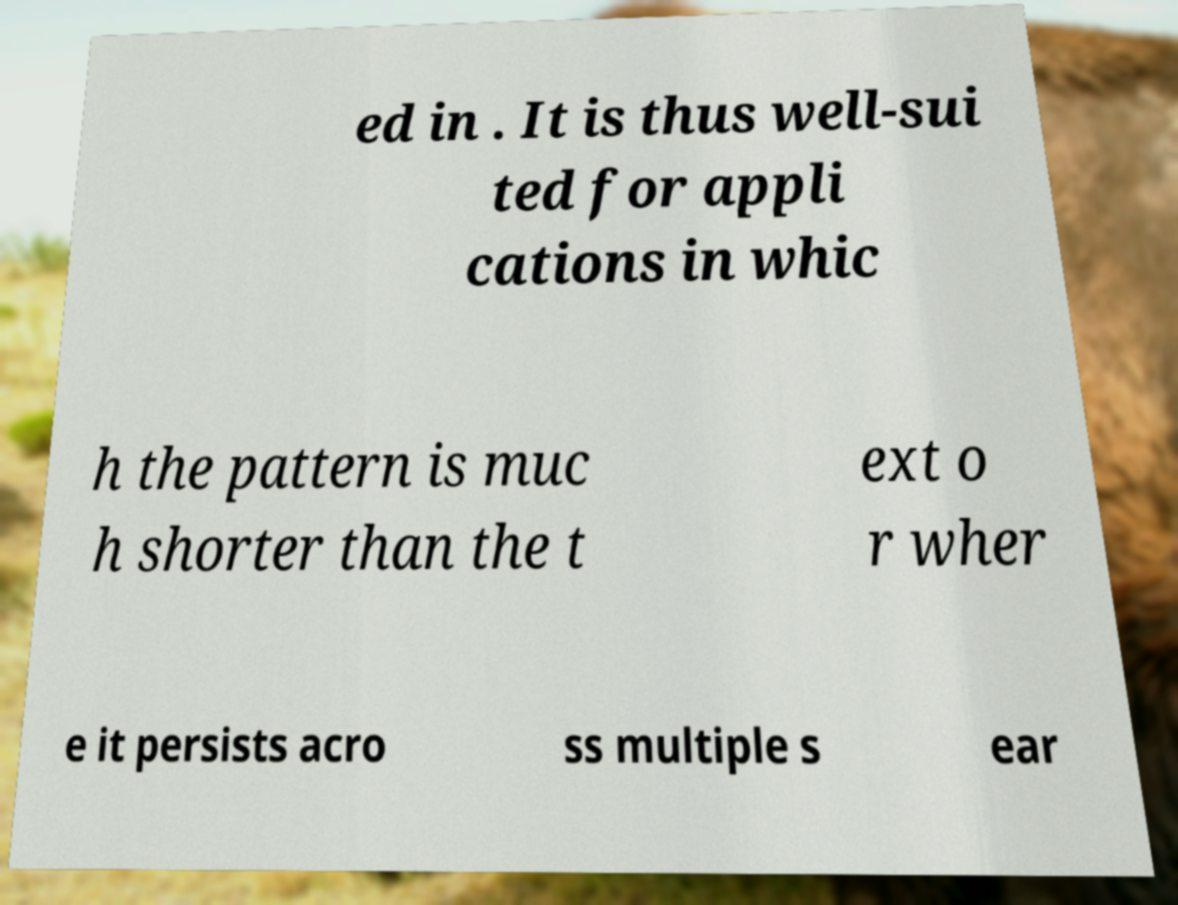Could you assist in decoding the text presented in this image and type it out clearly? ed in . It is thus well-sui ted for appli cations in whic h the pattern is muc h shorter than the t ext o r wher e it persists acro ss multiple s ear 